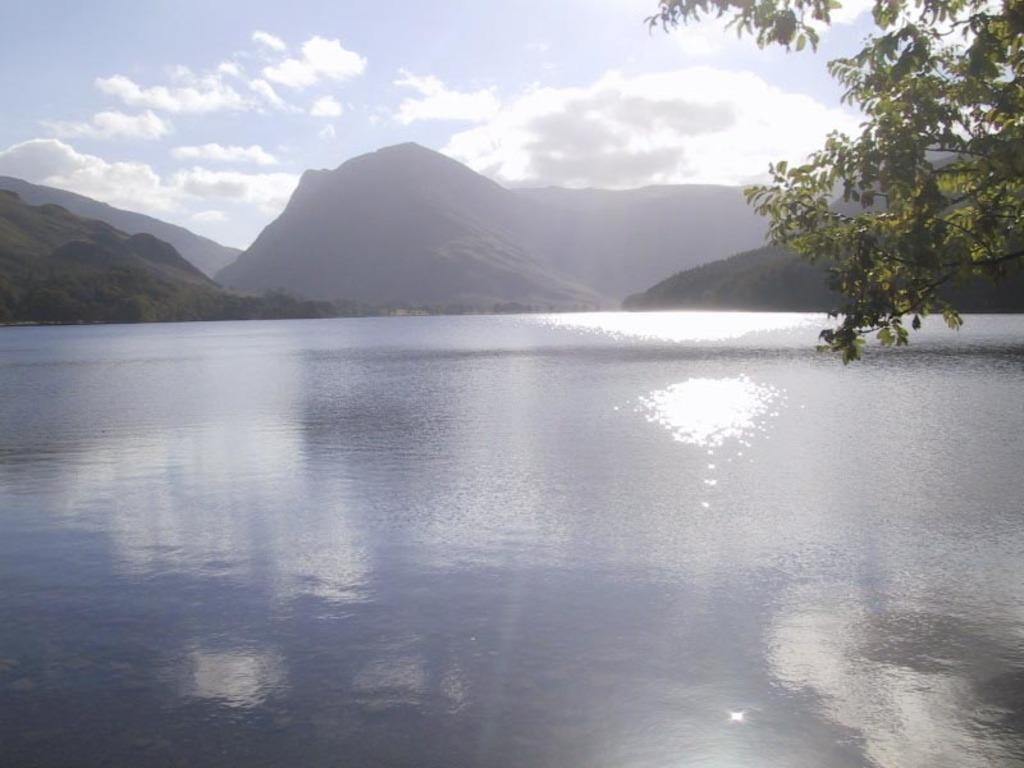What is present at the bottom of the image? There is water at the bottom of the image. What can be seen in the distance in the image? There are hills in the background of the image. Where is the tree located in the image? The tree is on the right side top of the image. What time does the clock show in the image? There is no clock present in the image. How many pins can be seen in the image? There are no pins present in the image. 